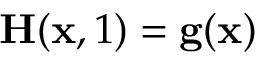<formula> <loc_0><loc_0><loc_500><loc_500>H ( x , 1 ) = g ( x )</formula> 